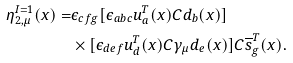Convert formula to latex. <formula><loc_0><loc_0><loc_500><loc_500>\eta ^ { I = 1 } _ { 2 , \mu } ( x ) = & \epsilon _ { c f g } [ \epsilon _ { a b c } u ^ { T } _ { a } ( x ) C d _ { b } ( x ) ] \\ & \times [ \epsilon _ { d e f } u ^ { T } _ { d } ( x ) C \gamma _ { \mu } d _ { e } ( x ) ] C \overline { s } ^ { T } _ { g } ( x ) .</formula> 